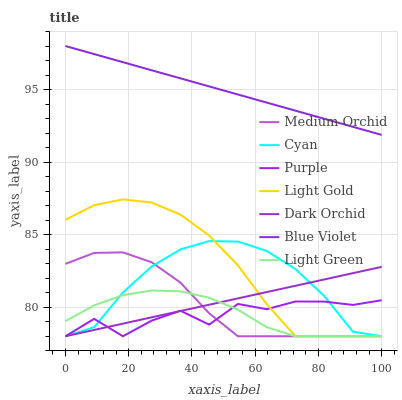Does Light Green have the minimum area under the curve?
Answer yes or no. Yes. Does Blue Violet have the maximum area under the curve?
Answer yes or no. Yes. Does Medium Orchid have the minimum area under the curve?
Answer yes or no. No. Does Medium Orchid have the maximum area under the curve?
Answer yes or no. No. Is Dark Orchid the smoothest?
Answer yes or no. Yes. Is Purple the roughest?
Answer yes or no. Yes. Is Medium Orchid the smoothest?
Answer yes or no. No. Is Medium Orchid the roughest?
Answer yes or no. No. Does Purple have the lowest value?
Answer yes or no. Yes. Does Blue Violet have the lowest value?
Answer yes or no. No. Does Blue Violet have the highest value?
Answer yes or no. Yes. Does Medium Orchid have the highest value?
Answer yes or no. No. Is Purple less than Blue Violet?
Answer yes or no. Yes. Is Blue Violet greater than Dark Orchid?
Answer yes or no. Yes. Does Dark Orchid intersect Medium Orchid?
Answer yes or no. Yes. Is Dark Orchid less than Medium Orchid?
Answer yes or no. No. Is Dark Orchid greater than Medium Orchid?
Answer yes or no. No. Does Purple intersect Blue Violet?
Answer yes or no. No. 